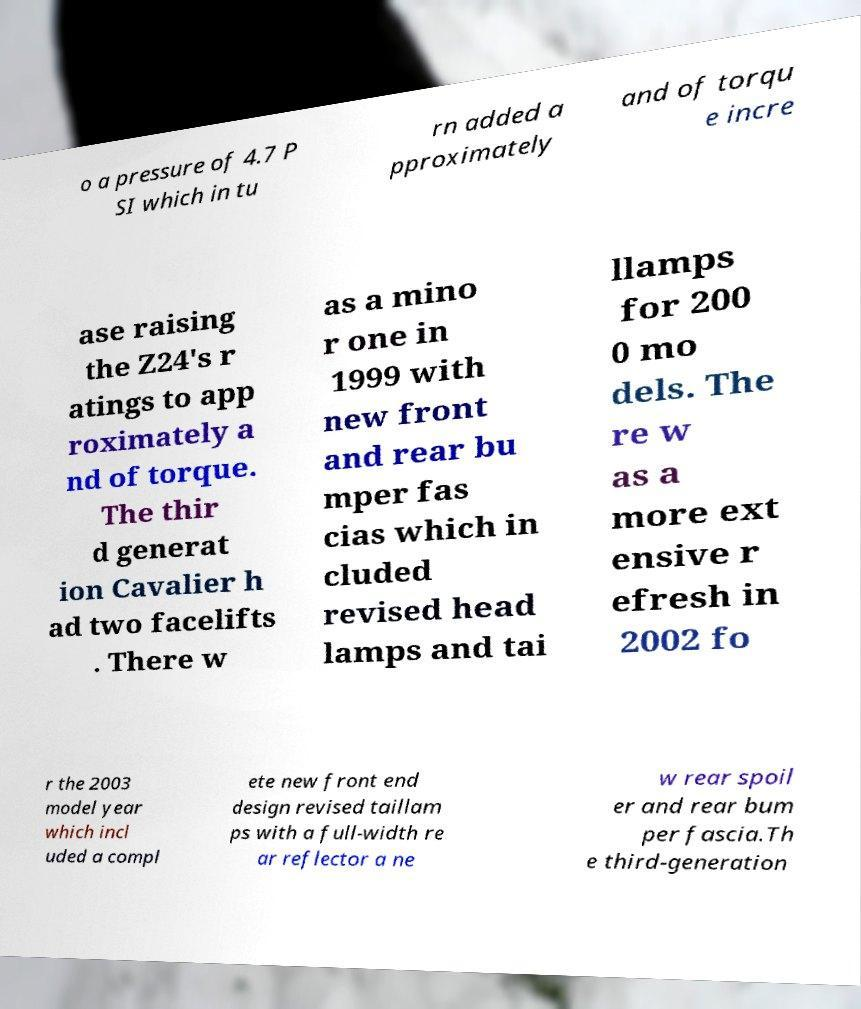What messages or text are displayed in this image? I need them in a readable, typed format. o a pressure of 4.7 P SI which in tu rn added a pproximately and of torqu e incre ase raising the Z24's r atings to app roximately a nd of torque. The thir d generat ion Cavalier h ad two facelifts . There w as a mino r one in 1999 with new front and rear bu mper fas cias which in cluded revised head lamps and tai llamps for 200 0 mo dels. The re w as a more ext ensive r efresh in 2002 fo r the 2003 model year which incl uded a compl ete new front end design revised taillam ps with a full-width re ar reflector a ne w rear spoil er and rear bum per fascia.Th e third-generation 